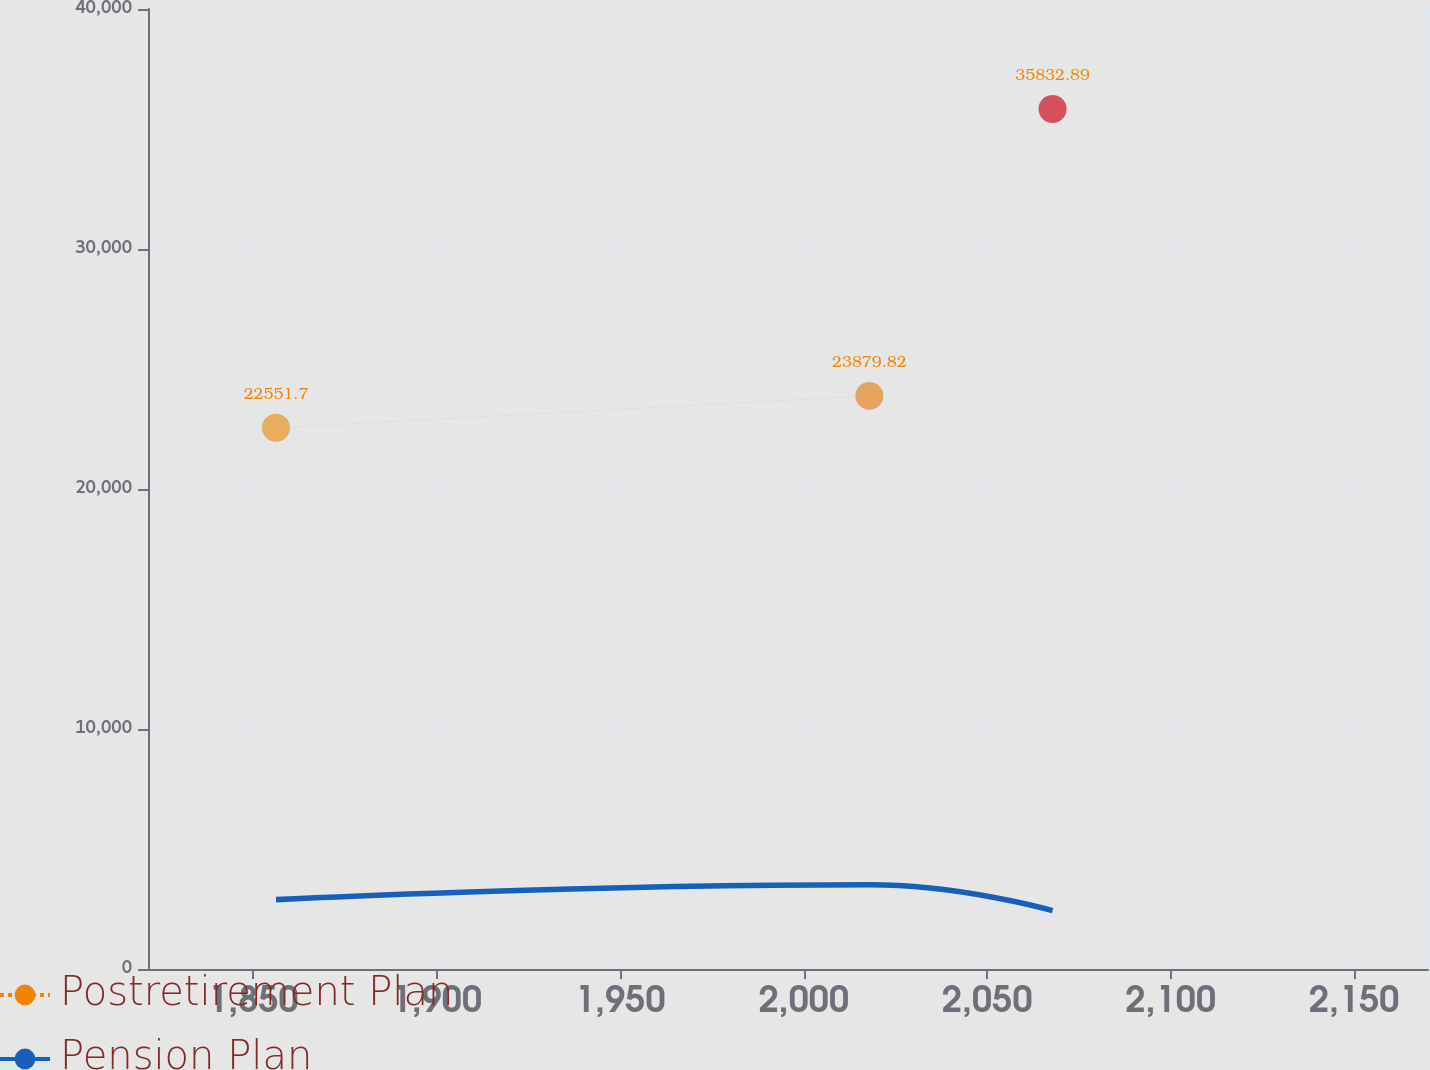Convert chart. <chart><loc_0><loc_0><loc_500><loc_500><line_chart><ecel><fcel>Postretirement Plan<fcel>Pension Plan<nl><fcel>1856.17<fcel>22551.7<fcel>2891.31<nl><fcel>2017.88<fcel>23879.8<fcel>3510.42<nl><fcel>2067.81<fcel>35832.9<fcel>2432.01<nl><fcel>2173.06<fcel>28684.3<fcel>2682<nl><fcel>2205.01<fcel>25744.9<fcel>2539.85<nl></chart> 